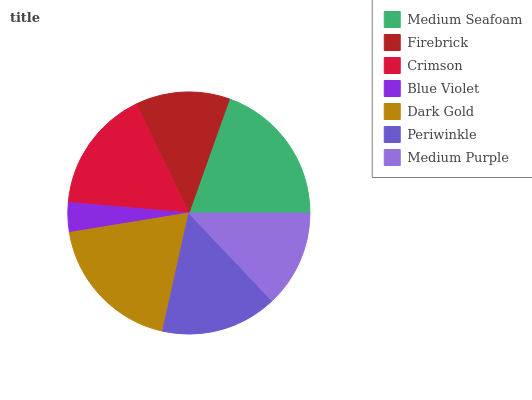Is Blue Violet the minimum?
Answer yes or no. Yes. Is Medium Seafoam the maximum?
Answer yes or no. Yes. Is Firebrick the minimum?
Answer yes or no. No. Is Firebrick the maximum?
Answer yes or no. No. Is Medium Seafoam greater than Firebrick?
Answer yes or no. Yes. Is Firebrick less than Medium Seafoam?
Answer yes or no. Yes. Is Firebrick greater than Medium Seafoam?
Answer yes or no. No. Is Medium Seafoam less than Firebrick?
Answer yes or no. No. Is Periwinkle the high median?
Answer yes or no. Yes. Is Periwinkle the low median?
Answer yes or no. Yes. Is Medium Seafoam the high median?
Answer yes or no. No. Is Medium Seafoam the low median?
Answer yes or no. No. 